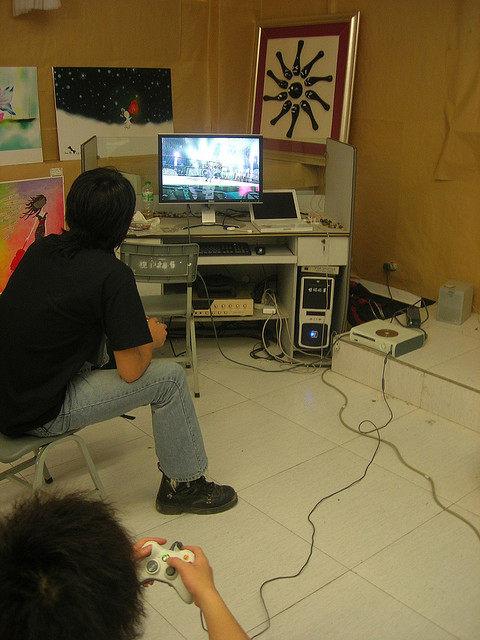Imagine if this scene was part of a sci-fi movie. What role would this room play in the storyline? In a sci-fi movie, this room could serve as the headquarters for a group of digital warriors who use advanced technology and immersive games to train for real-world missions. The high-tech equipment could be linked to a larger network, allowing the characters to simulate various scenarios and develop strategies. The imaginative artworks on the walls might symbolize the creative thinking necessary to outsmart their adversaries. This space would be a hub of strategic planning and virtual combat training, crucial for the heroes' preparation against futuristic threats. Given the setup, what unique elements might this room have if it were part of a dystopian video game world? In a dystopian video game world, this room could incorporate augmented reality elements where the artworks on the walls are interactive and change according to game progress. The equipment might include biometric scanners and neural interfaces to fully immerse the player in the game, blurring the line between reality and virtual reality. The room could have hidden compartments with essential items for survival in game missions. Additionally, the lighting could be adaptive, shifting to dim settings during stealth missions or glowing brightly in moments of action-packed gameplay. This setup would enhance the immersive experience, making the room a pivotal setting in the dystopian narrative. 